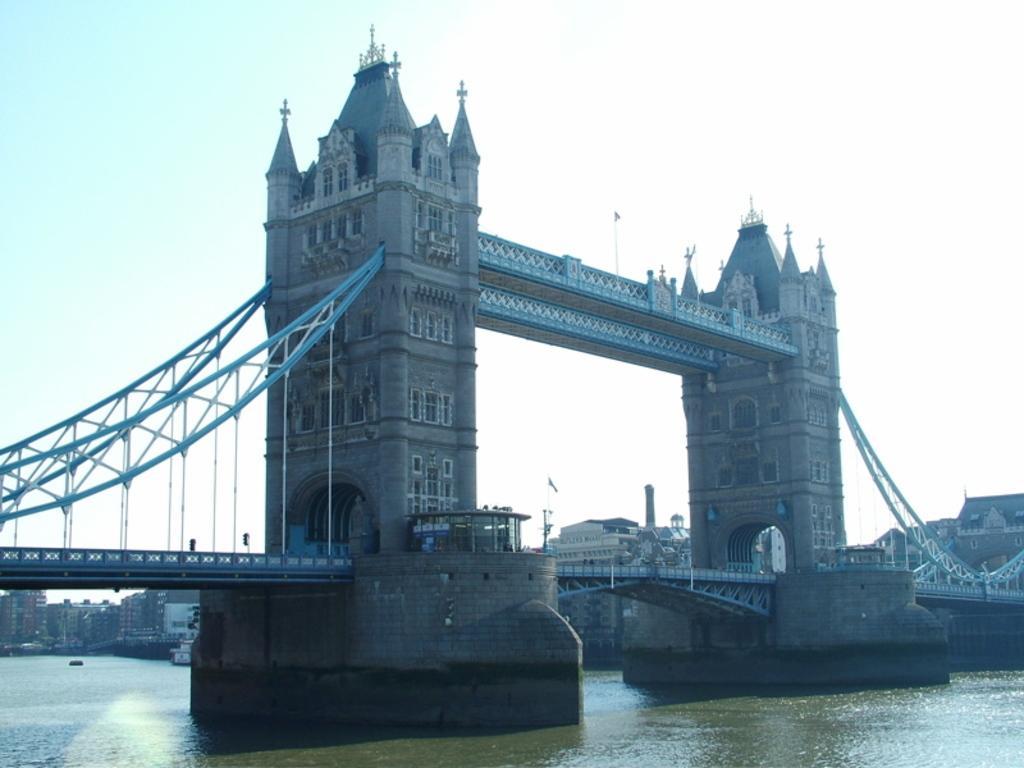Could you give a brief overview of what you see in this image? In the picture I can see a lake, on it there is a abridge, side we can see so many buildings. 